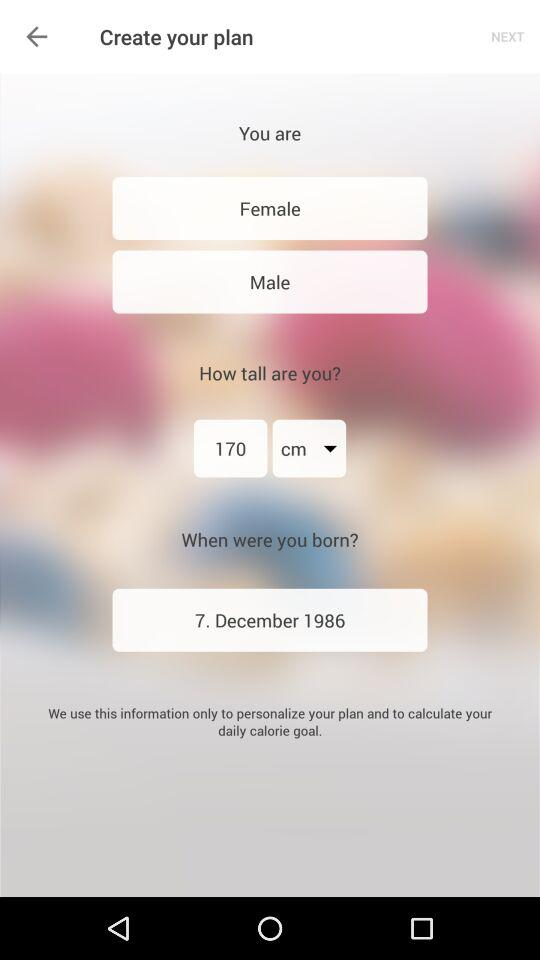How many gender options are there?
Answer the question using a single word or phrase. 2 